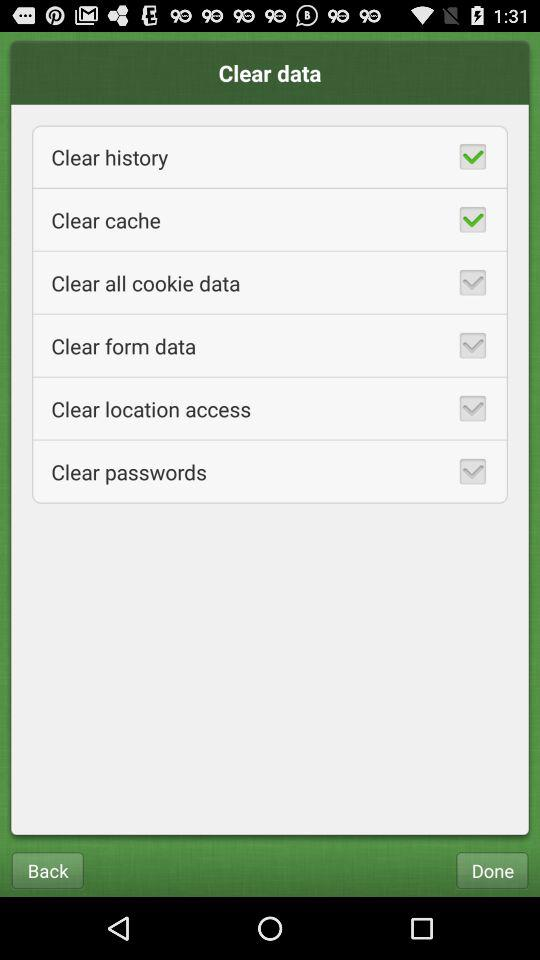What is the status of the cache? The status is on. 